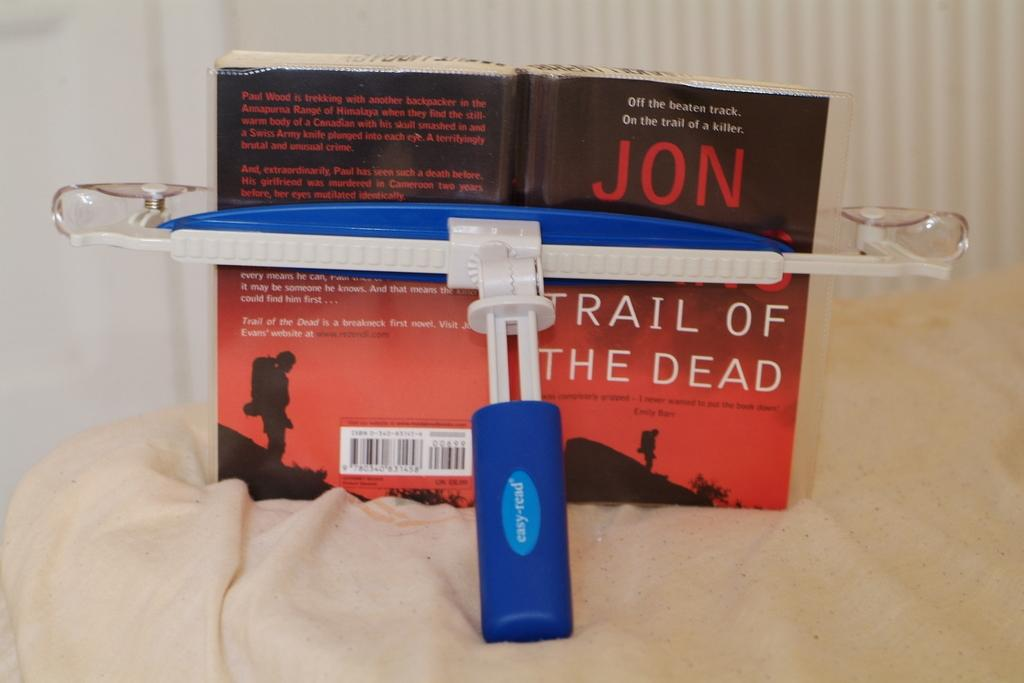<image>
Offer a succinct explanation of the picture presented. a book that is called 'trail of the dead' by jon something 